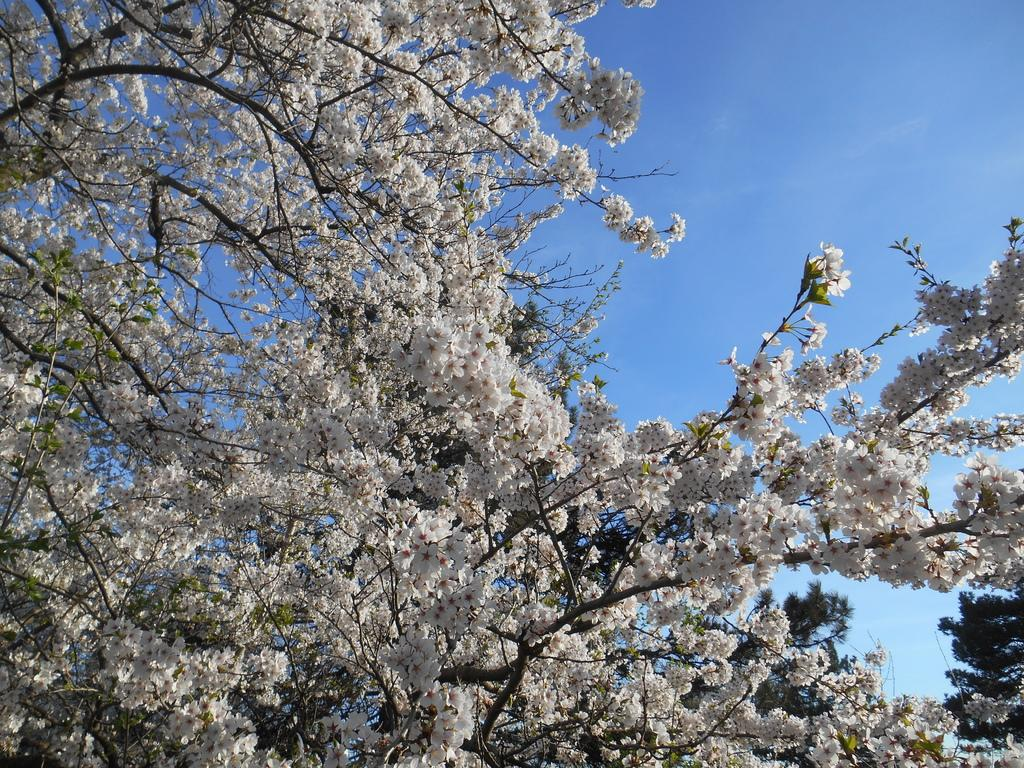What type of trees are in the image? There are trees with white color flowers in the image. Where are the trees located in the image? The trees are in the middle of the image. What can be seen in the background of the image? There is a sky visible in the background of the image. What type of dress is hanging on the tree in the image? There is no dress present in the image; it features trees with white color flowers. How does the tree shake in the image? The tree does not shake in the image; it is stationary. 